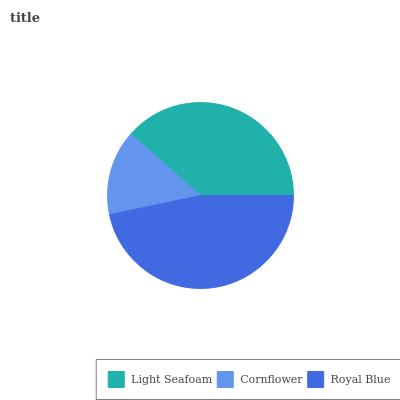Is Cornflower the minimum?
Answer yes or no. Yes. Is Royal Blue the maximum?
Answer yes or no. Yes. Is Royal Blue the minimum?
Answer yes or no. No. Is Cornflower the maximum?
Answer yes or no. No. Is Royal Blue greater than Cornflower?
Answer yes or no. Yes. Is Cornflower less than Royal Blue?
Answer yes or no. Yes. Is Cornflower greater than Royal Blue?
Answer yes or no. No. Is Royal Blue less than Cornflower?
Answer yes or no. No. Is Light Seafoam the high median?
Answer yes or no. Yes. Is Light Seafoam the low median?
Answer yes or no. Yes. Is Royal Blue the high median?
Answer yes or no. No. Is Royal Blue the low median?
Answer yes or no. No. 